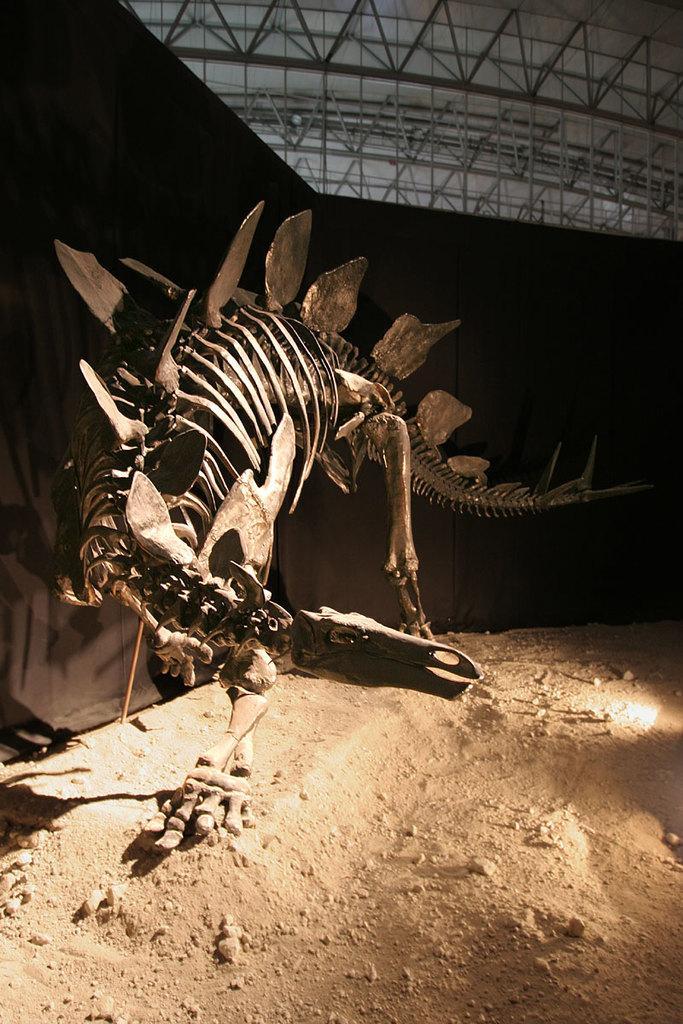Could you give a brief overview of what you see in this image? This image is taken indoors. At the bottom of the image there is a ground. In the middle of the image there is an artificial skeleton of a dinosaur. In the background there is a wall. At the top of the image there is a roof. 